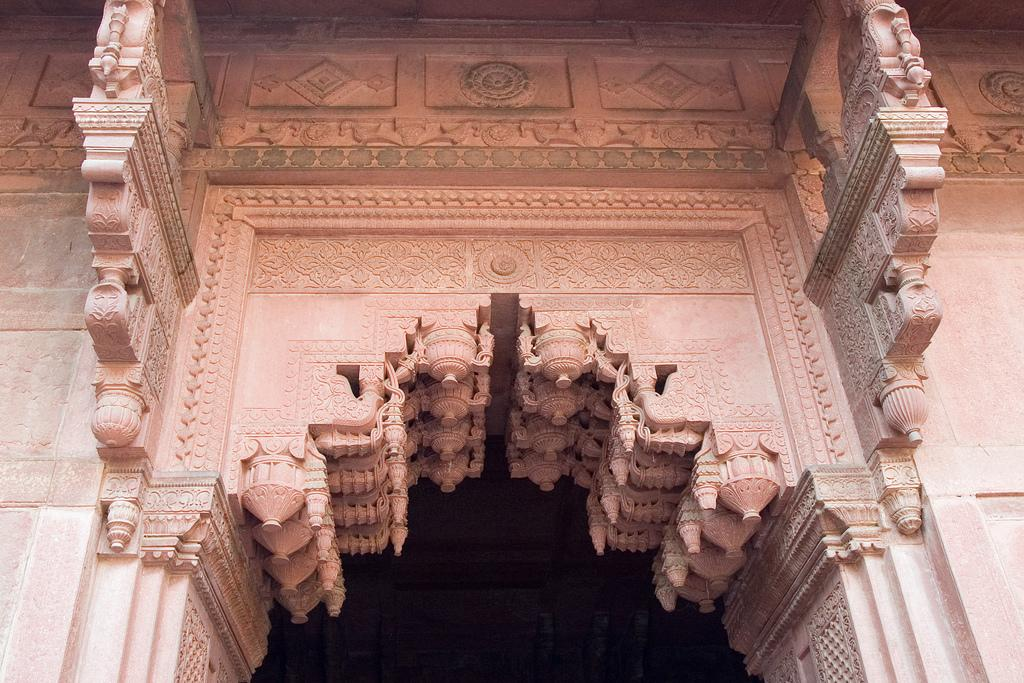What can be seen on the wall in the image? There is carving on the wall in the image. What is the color of the background behind the wall? The background behind the wall is dark. What type of alley is visible in the image? There is no alley present in the image; it only features a wall with carving and a dark background. 